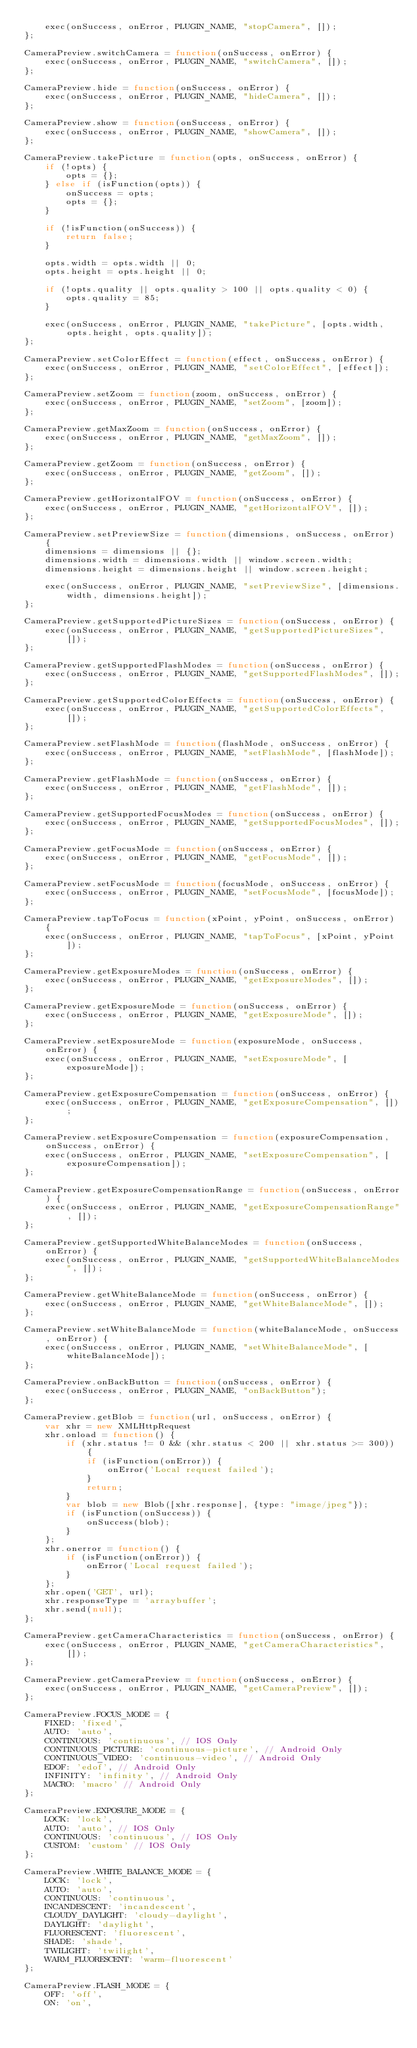<code> <loc_0><loc_0><loc_500><loc_500><_JavaScript_>    exec(onSuccess, onError, PLUGIN_NAME, "stopCamera", []);
};

CameraPreview.switchCamera = function(onSuccess, onError) {
    exec(onSuccess, onError, PLUGIN_NAME, "switchCamera", []);
};

CameraPreview.hide = function(onSuccess, onError) {
    exec(onSuccess, onError, PLUGIN_NAME, "hideCamera", []);
};

CameraPreview.show = function(onSuccess, onError) {
    exec(onSuccess, onError, PLUGIN_NAME, "showCamera", []);
};

CameraPreview.takePicture = function(opts, onSuccess, onError) {
    if (!opts) {
        opts = {};
    } else if (isFunction(opts)) {
        onSuccess = opts;
        opts = {};
    }

    if (!isFunction(onSuccess)) {
        return false;
    }

    opts.width = opts.width || 0;
    opts.height = opts.height || 0;

    if (!opts.quality || opts.quality > 100 || opts.quality < 0) {
        opts.quality = 85;
    }

    exec(onSuccess, onError, PLUGIN_NAME, "takePicture", [opts.width, opts.height, opts.quality]);
};

CameraPreview.setColorEffect = function(effect, onSuccess, onError) {
    exec(onSuccess, onError, PLUGIN_NAME, "setColorEffect", [effect]);
};

CameraPreview.setZoom = function(zoom, onSuccess, onError) {
    exec(onSuccess, onError, PLUGIN_NAME, "setZoom", [zoom]);
};

CameraPreview.getMaxZoom = function(onSuccess, onError) {
    exec(onSuccess, onError, PLUGIN_NAME, "getMaxZoom", []);
};

CameraPreview.getZoom = function(onSuccess, onError) {
    exec(onSuccess, onError, PLUGIN_NAME, "getZoom", []);
};

CameraPreview.getHorizontalFOV = function(onSuccess, onError) {
    exec(onSuccess, onError, PLUGIN_NAME, "getHorizontalFOV", []);
};

CameraPreview.setPreviewSize = function(dimensions, onSuccess, onError) {
    dimensions = dimensions || {};
    dimensions.width = dimensions.width || window.screen.width;
    dimensions.height = dimensions.height || window.screen.height;

    exec(onSuccess, onError, PLUGIN_NAME, "setPreviewSize", [dimensions.width, dimensions.height]);
};

CameraPreview.getSupportedPictureSizes = function(onSuccess, onError) {
    exec(onSuccess, onError, PLUGIN_NAME, "getSupportedPictureSizes", []);
};

CameraPreview.getSupportedFlashModes = function(onSuccess, onError) {
    exec(onSuccess, onError, PLUGIN_NAME, "getSupportedFlashModes", []);
};

CameraPreview.getSupportedColorEffects = function(onSuccess, onError) {
    exec(onSuccess, onError, PLUGIN_NAME, "getSupportedColorEffects", []);
};

CameraPreview.setFlashMode = function(flashMode, onSuccess, onError) {
    exec(onSuccess, onError, PLUGIN_NAME, "setFlashMode", [flashMode]);
};

CameraPreview.getFlashMode = function(onSuccess, onError) {
    exec(onSuccess, onError, PLUGIN_NAME, "getFlashMode", []);
};

CameraPreview.getSupportedFocusModes = function(onSuccess, onError) {
    exec(onSuccess, onError, PLUGIN_NAME, "getSupportedFocusModes", []);
};

CameraPreview.getFocusMode = function(onSuccess, onError) {
    exec(onSuccess, onError, PLUGIN_NAME, "getFocusMode", []);
};

CameraPreview.setFocusMode = function(focusMode, onSuccess, onError) {
    exec(onSuccess, onError, PLUGIN_NAME, "setFocusMode", [focusMode]);
};

CameraPreview.tapToFocus = function(xPoint, yPoint, onSuccess, onError) {
    exec(onSuccess, onError, PLUGIN_NAME, "tapToFocus", [xPoint, yPoint]);
};

CameraPreview.getExposureModes = function(onSuccess, onError) {
    exec(onSuccess, onError, PLUGIN_NAME, "getExposureModes", []);
};

CameraPreview.getExposureMode = function(onSuccess, onError) {
    exec(onSuccess, onError, PLUGIN_NAME, "getExposureMode", []);
};

CameraPreview.setExposureMode = function(exposureMode, onSuccess, onError) {
    exec(onSuccess, onError, PLUGIN_NAME, "setExposureMode", [exposureMode]);
};

CameraPreview.getExposureCompensation = function(onSuccess, onError) {
    exec(onSuccess, onError, PLUGIN_NAME, "getExposureCompensation", []);
};

CameraPreview.setExposureCompensation = function(exposureCompensation, onSuccess, onError) {
    exec(onSuccess, onError, PLUGIN_NAME, "setExposureCompensation", [exposureCompensation]);
};

CameraPreview.getExposureCompensationRange = function(onSuccess, onError) {
    exec(onSuccess, onError, PLUGIN_NAME, "getExposureCompensationRange", []);
};

CameraPreview.getSupportedWhiteBalanceModes = function(onSuccess, onError) {
    exec(onSuccess, onError, PLUGIN_NAME, "getSupportedWhiteBalanceModes", []);
};

CameraPreview.getWhiteBalanceMode = function(onSuccess, onError) {
    exec(onSuccess, onError, PLUGIN_NAME, "getWhiteBalanceMode", []);
};

CameraPreview.setWhiteBalanceMode = function(whiteBalanceMode, onSuccess, onError) {
    exec(onSuccess, onError, PLUGIN_NAME, "setWhiteBalanceMode", [whiteBalanceMode]);
};

CameraPreview.onBackButton = function(onSuccess, onError) {
    exec(onSuccess, onError, PLUGIN_NAME, "onBackButton");
};

CameraPreview.getBlob = function(url, onSuccess, onError) {
    var xhr = new XMLHttpRequest
    xhr.onload = function() {
        if (xhr.status != 0 && (xhr.status < 200 || xhr.status >= 300)) {
            if (isFunction(onError)) {
                onError('Local request failed');
            }
            return;
        }
        var blob = new Blob([xhr.response], {type: "image/jpeg"});
        if (isFunction(onSuccess)) {
            onSuccess(blob);
        }
    };
    xhr.onerror = function() {
        if (isFunction(onError)) {
            onError('Local request failed');
        }
    };
    xhr.open('GET', url);
    xhr.responseType = 'arraybuffer';
    xhr.send(null);
};

CameraPreview.getCameraCharacteristics = function(onSuccess, onError) {
    exec(onSuccess, onError, PLUGIN_NAME, "getCameraCharacteristics", []);
};

CameraPreview.getCameraPreview = function(onSuccess, onError) {
    exec(onSuccess, onError, PLUGIN_NAME, "getCameraPreview", []);
};

CameraPreview.FOCUS_MODE = {
    FIXED: 'fixed',
    AUTO: 'auto',
    CONTINUOUS: 'continuous', // IOS Only
    CONTINUOUS_PICTURE: 'continuous-picture', // Android Only
    CONTINUOUS_VIDEO: 'continuous-video', // Android Only
    EDOF: 'edof', // Android Only
    INFINITY: 'infinity', // Android Only
    MACRO: 'macro' // Android Only
};

CameraPreview.EXPOSURE_MODE = {
    LOCK: 'lock',
    AUTO: 'auto', // IOS Only
    CONTINUOUS: 'continuous', // IOS Only
    CUSTOM: 'custom' // IOS Only
};

CameraPreview.WHITE_BALANCE_MODE = {
    LOCK: 'lock',
    AUTO: 'auto',
    CONTINUOUS: 'continuous',
    INCANDESCENT: 'incandescent',
    CLOUDY_DAYLIGHT: 'cloudy-daylight',
    DAYLIGHT: 'daylight',
    FLUORESCENT: 'fluorescent',
    SHADE: 'shade',
    TWILIGHT: 'twilight',
    WARM_FLUORESCENT: 'warm-fluorescent'
};

CameraPreview.FLASH_MODE = {
    OFF: 'off',
    ON: 'on',</code> 